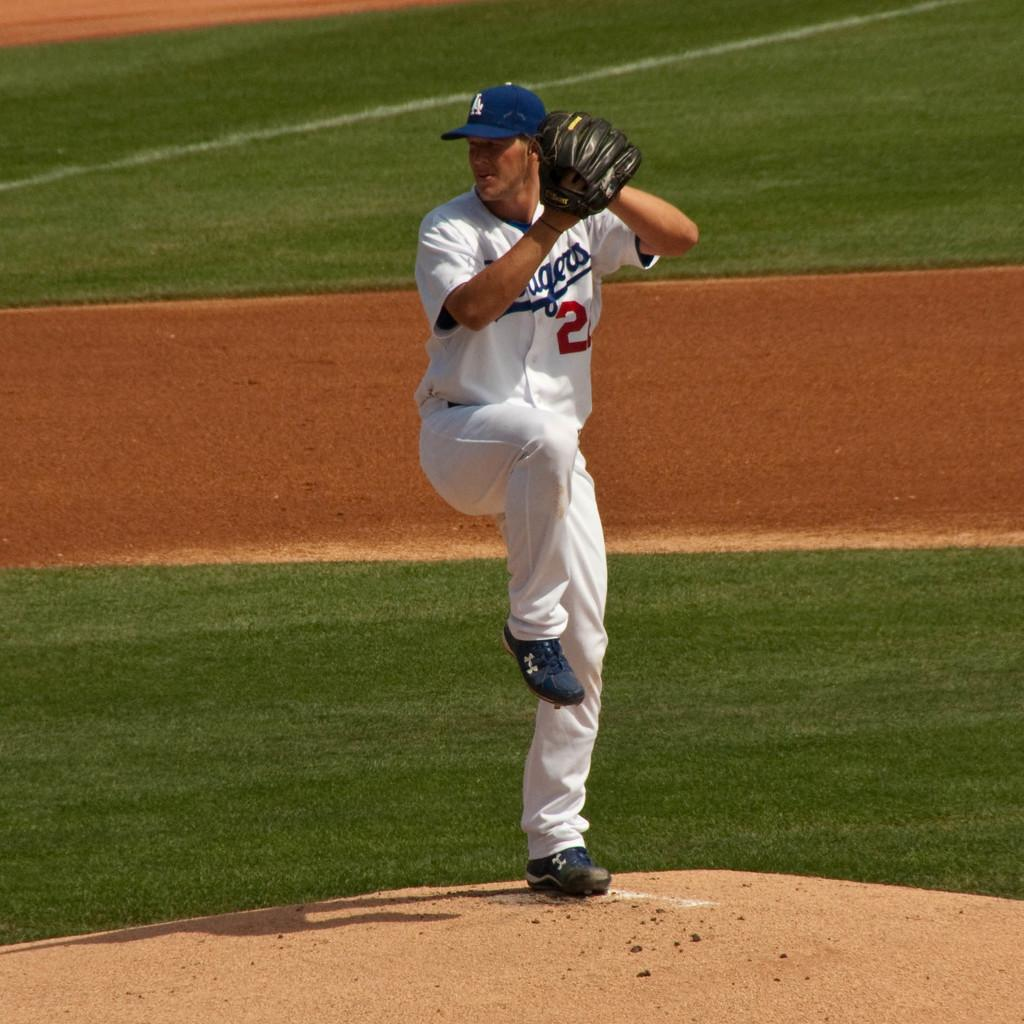<image>
Present a compact description of the photo's key features. A baseball pitcher is wearing a Dodgers uniform. 